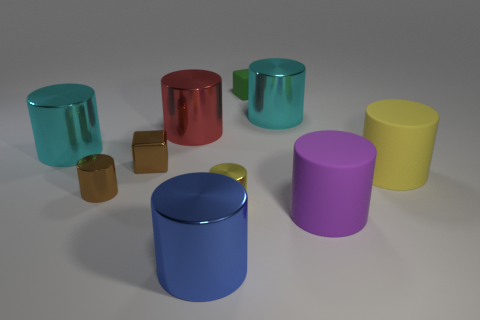Can you describe the lighting and how it affects the appearance of the objects? The image is illuminated with a soft, diffused light that minimizes harsh shadows, enhancing the objects' three-dimensional qualities and showcasing their metallic and rubber textures in a gentle way, thus highlighting their colors and forms. 